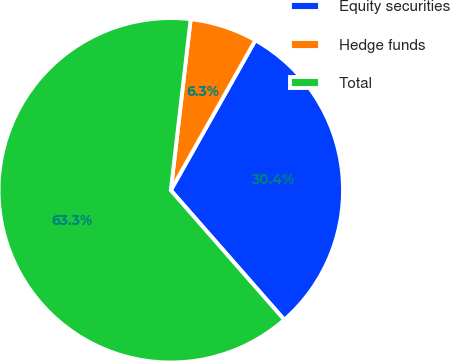Convert chart to OTSL. <chart><loc_0><loc_0><loc_500><loc_500><pie_chart><fcel>Equity securities<fcel>Hedge funds<fcel>Total<nl><fcel>30.38%<fcel>6.33%<fcel>63.29%<nl></chart> 